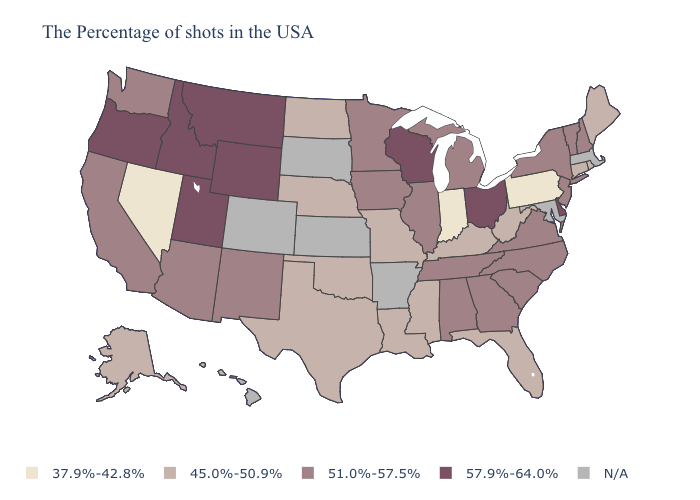What is the highest value in the South ?
Short answer required. 57.9%-64.0%. What is the highest value in the West ?
Give a very brief answer. 57.9%-64.0%. Name the states that have a value in the range 51.0%-57.5%?
Write a very short answer. New Hampshire, Vermont, New York, New Jersey, Virginia, North Carolina, South Carolina, Georgia, Michigan, Alabama, Tennessee, Illinois, Minnesota, Iowa, New Mexico, Arizona, California, Washington. Among the states that border Vermont , which have the highest value?
Write a very short answer. New Hampshire, New York. What is the value of Ohio?
Write a very short answer. 57.9%-64.0%. What is the lowest value in the South?
Quick response, please. 45.0%-50.9%. What is the value of New Mexico?
Answer briefly. 51.0%-57.5%. Does Utah have the highest value in the USA?
Concise answer only. Yes. What is the value of New Hampshire?
Write a very short answer. 51.0%-57.5%. Which states have the highest value in the USA?
Give a very brief answer. Delaware, Ohio, Wisconsin, Wyoming, Utah, Montana, Idaho, Oregon. Does the first symbol in the legend represent the smallest category?
Give a very brief answer. Yes. Name the states that have a value in the range N/A?
Be succinct. Massachusetts, Maryland, Arkansas, Kansas, South Dakota, Colorado, Hawaii. Which states have the highest value in the USA?
Write a very short answer. Delaware, Ohio, Wisconsin, Wyoming, Utah, Montana, Idaho, Oregon. Among the states that border Missouri , does Illinois have the highest value?
Short answer required. Yes. What is the value of Texas?
Concise answer only. 45.0%-50.9%. 